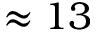Convert formula to latex. <formula><loc_0><loc_0><loc_500><loc_500>\approx 1 3</formula> 